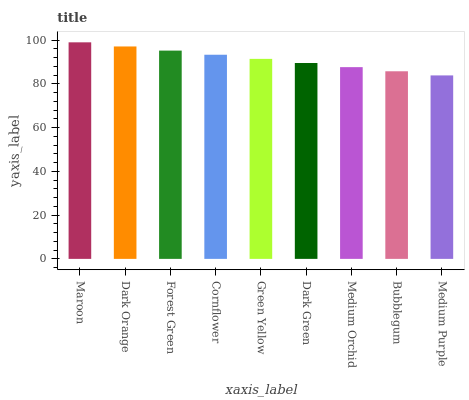Is Medium Purple the minimum?
Answer yes or no. Yes. Is Maroon the maximum?
Answer yes or no. Yes. Is Dark Orange the minimum?
Answer yes or no. No. Is Dark Orange the maximum?
Answer yes or no. No. Is Maroon greater than Dark Orange?
Answer yes or no. Yes. Is Dark Orange less than Maroon?
Answer yes or no. Yes. Is Dark Orange greater than Maroon?
Answer yes or no. No. Is Maroon less than Dark Orange?
Answer yes or no. No. Is Green Yellow the high median?
Answer yes or no. Yes. Is Green Yellow the low median?
Answer yes or no. Yes. Is Cornflower the high median?
Answer yes or no. No. Is Maroon the low median?
Answer yes or no. No. 